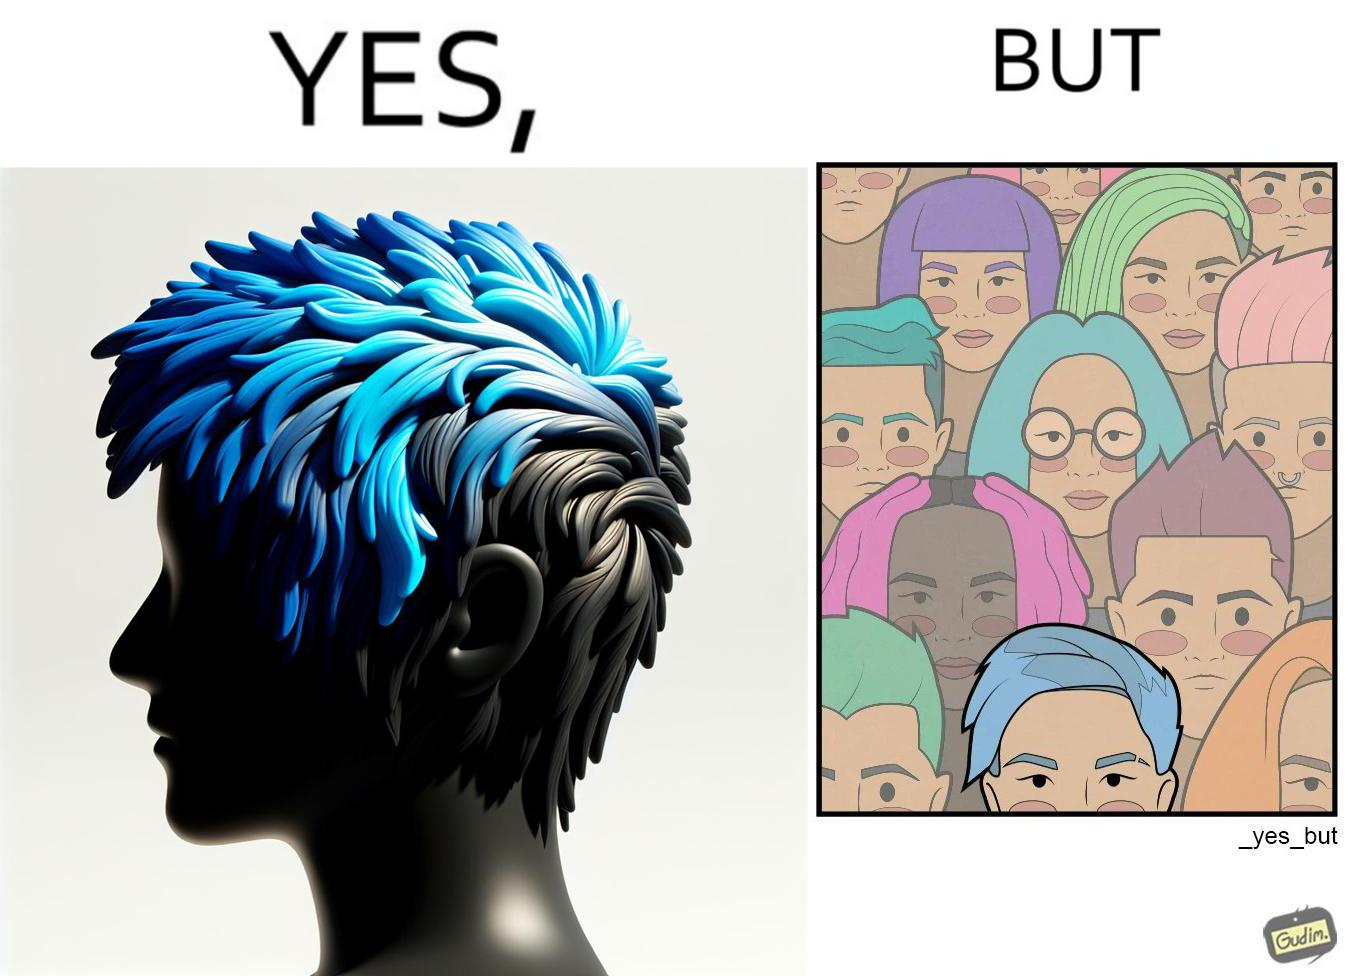Is there satirical content in this image? Yes, this image is satirical. 